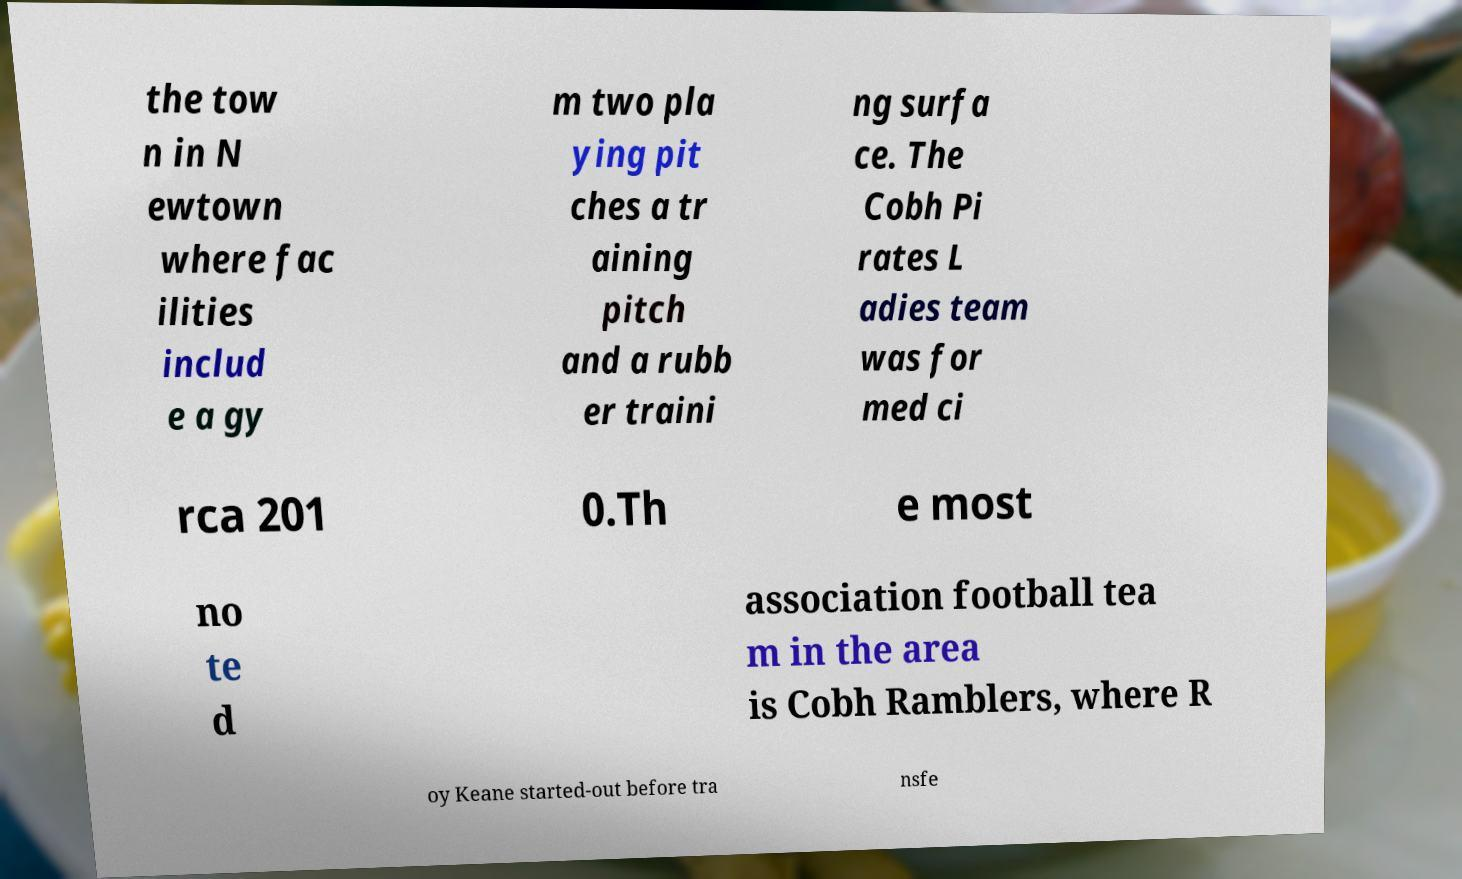Please read and relay the text visible in this image. What does it say? the tow n in N ewtown where fac ilities includ e a gy m two pla ying pit ches a tr aining pitch and a rubb er traini ng surfa ce. The Cobh Pi rates L adies team was for med ci rca 201 0.Th e most no te d association football tea m in the area is Cobh Ramblers, where R oy Keane started-out before tra nsfe 